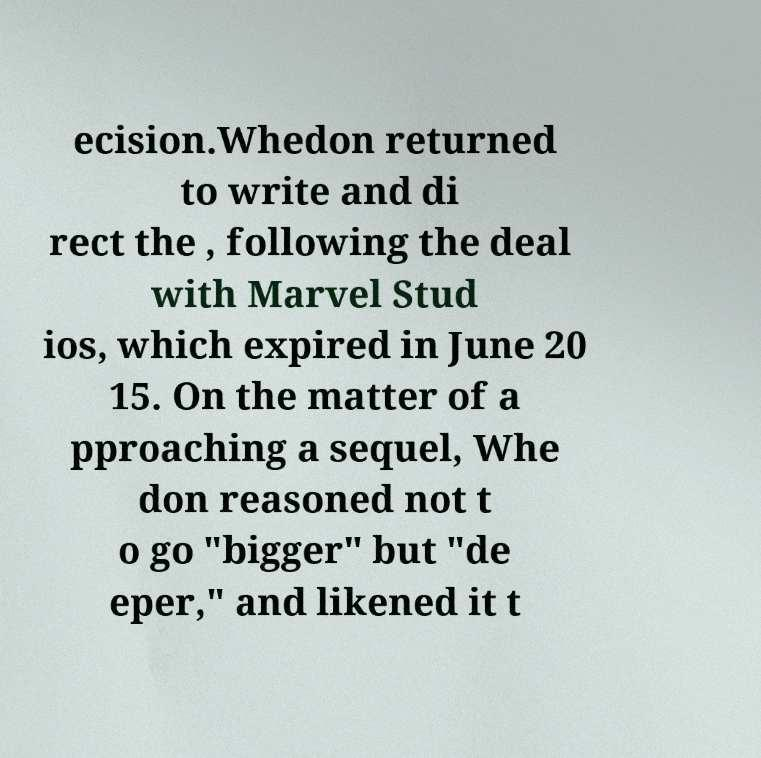There's text embedded in this image that I need extracted. Can you transcribe it verbatim? ecision.Whedon returned to write and di rect the , following the deal with Marvel Stud ios, which expired in June 20 15. On the matter of a pproaching a sequel, Whe don reasoned not t o go "bigger" but "de eper," and likened it t 